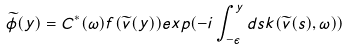<formula> <loc_0><loc_0><loc_500><loc_500>\widetilde { \phi } ( y ) = C ^ { * } ( \omega ) f ( \widetilde { v } ( y ) ) e x p ( - i \int _ { - \epsilon } ^ { y } d s k ( \widetilde { v } ( s ) , \omega ) )</formula> 